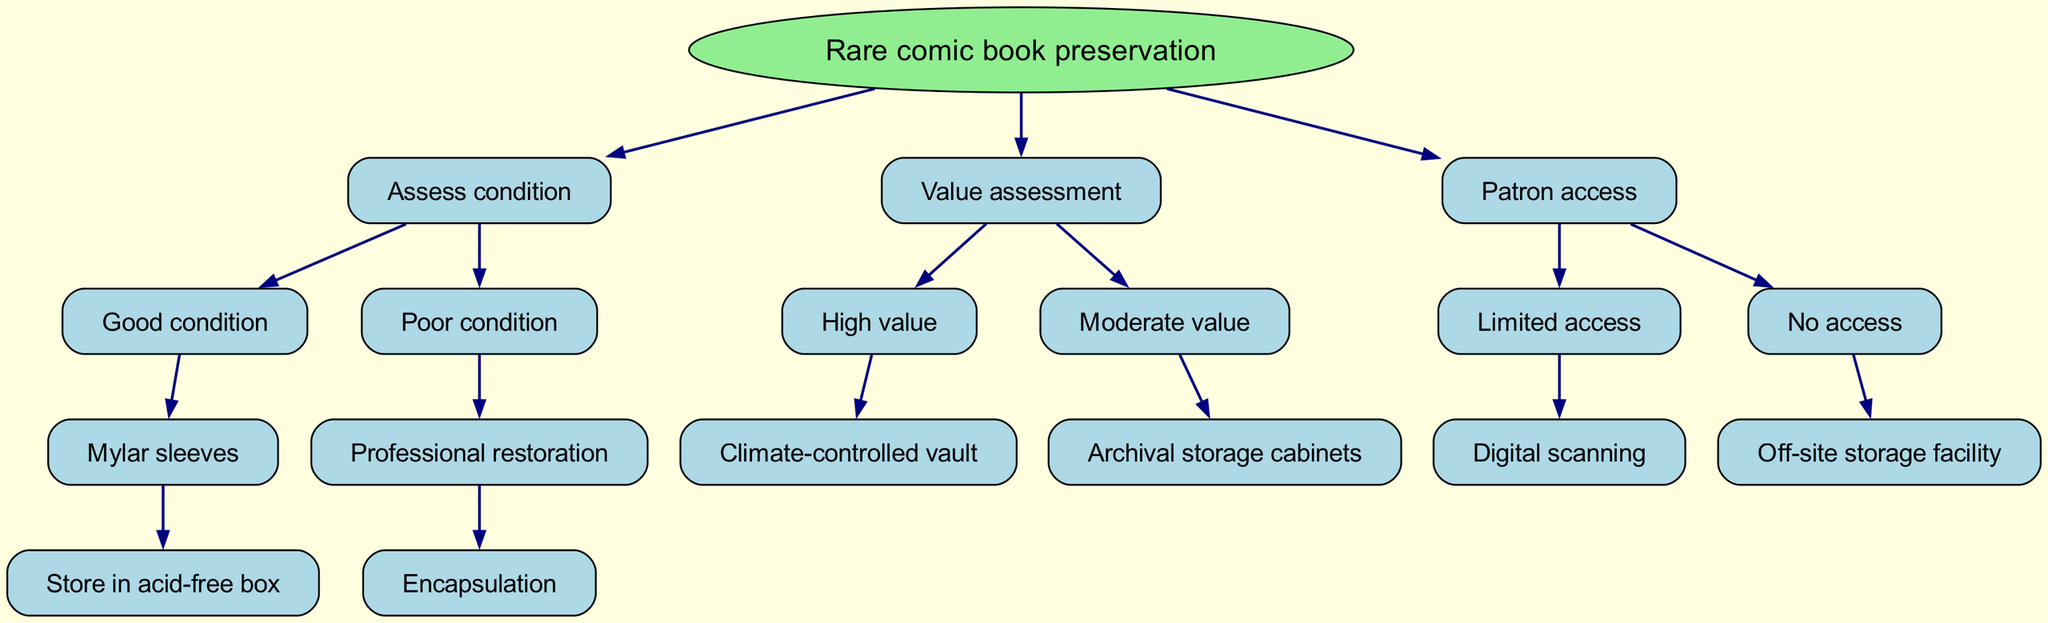What is the root of the decision tree? The root node represents the top-level category of the decision-making process, which in this case is 'Rare comic book preservation'.
Answer: Rare comic book preservation How many primary categories are there in the decision tree? There are three main categories (nodes) branching from the root: Assess condition, Value assessment, and Patron access.
Answer: 3 What preservation method is suggested for a comic book in good condition? The flow indicates that if a comic book is assessed as being in good condition, the recommended preservation method is to use Mylar sleeves.
Answer: Mylar sleeves Which preservation method is associated with high-value comic books? The decision tree specifies that high-value comic books should be stored in a climate-controlled vault for preservation.
Answer: Climate-controlled vault If a comic book is in poor condition, what is the first recommended action? The diagram suggests that for poor condition comic books, the initial recommendation is to seek professional restoration.
Answer: Professional restoration What could be a suitable storage option for moderately valued comic books? According to the decision tree, moderately valued comic books should be stored in archival storage cabinets.
Answer: Archival storage cabinets What is the recommended action if patron access to the comic books is limited? The diagram indicates that if patron access is limited, the recommendation is to proceed with digital scanning.
Answer: Digital scanning What type of storage is suggested when there is no access to the comic books? The decision tree indicates that with no access, the recommended option is to use an off-site storage facility.
Answer: Off-site storage facility How does 'Assess condition' relate to preservation methods? The 'Assess condition' category leads to recommendations based on whether the comic book is in good or poor condition, directly influencing the type of preservation method recommended.
Answer: Influences methods What does the 'children' node represent in this diagram? In this decision tree, the 'children' nodes represent the subsequent options or recommendations that result from decisions made at the parent node.
Answer: Subsequent options 